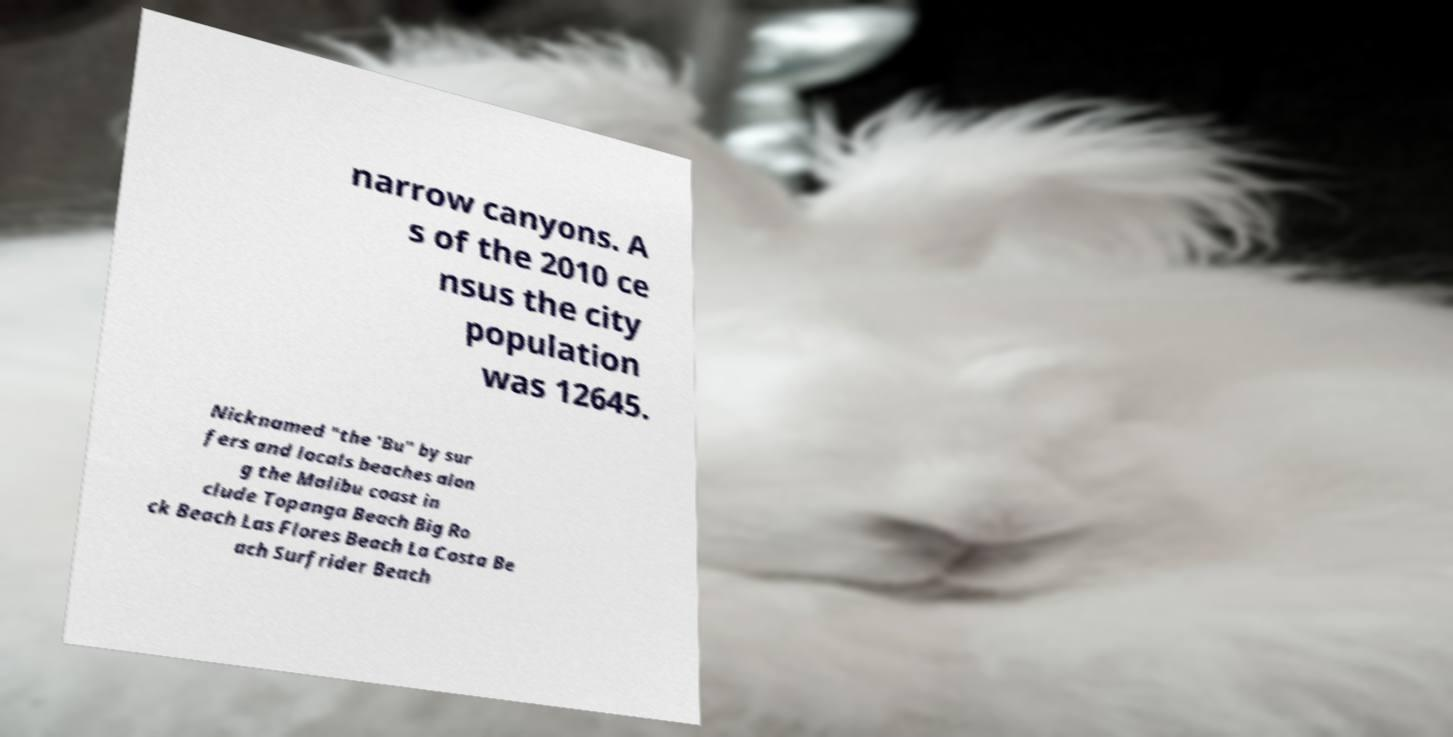Could you assist in decoding the text presented in this image and type it out clearly? narrow canyons. A s of the 2010 ce nsus the city population was 12645. Nicknamed "the 'Bu" by sur fers and locals beaches alon g the Malibu coast in clude Topanga Beach Big Ro ck Beach Las Flores Beach La Costa Be ach Surfrider Beach 